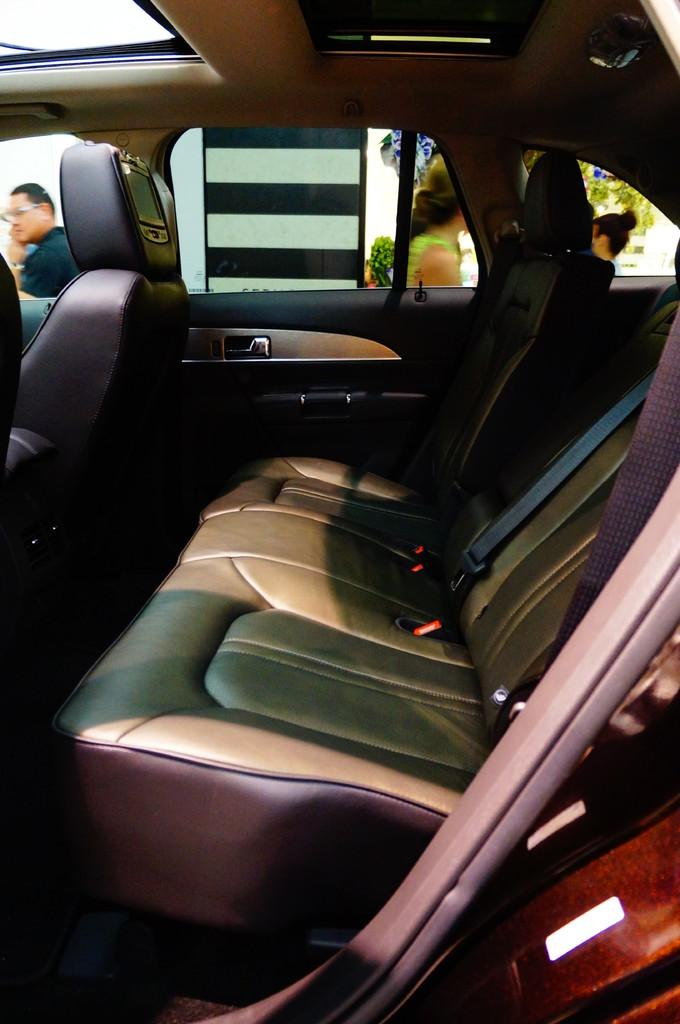What type of location is depicted in the image? The image is an inside view of a vehicle. What can be found inside the vehicle? There are seats and seat belts present in the vehicle. How can passengers enter or exit the vehicle? There is a door in the vehicle, and a handle is visible. Are there any people inside the vehicle? Yes, there are people inside the vehicle. What type of substance is being passed around by the stranger in the vehicle? There is no stranger present in the image, and no substance is being passed around. 